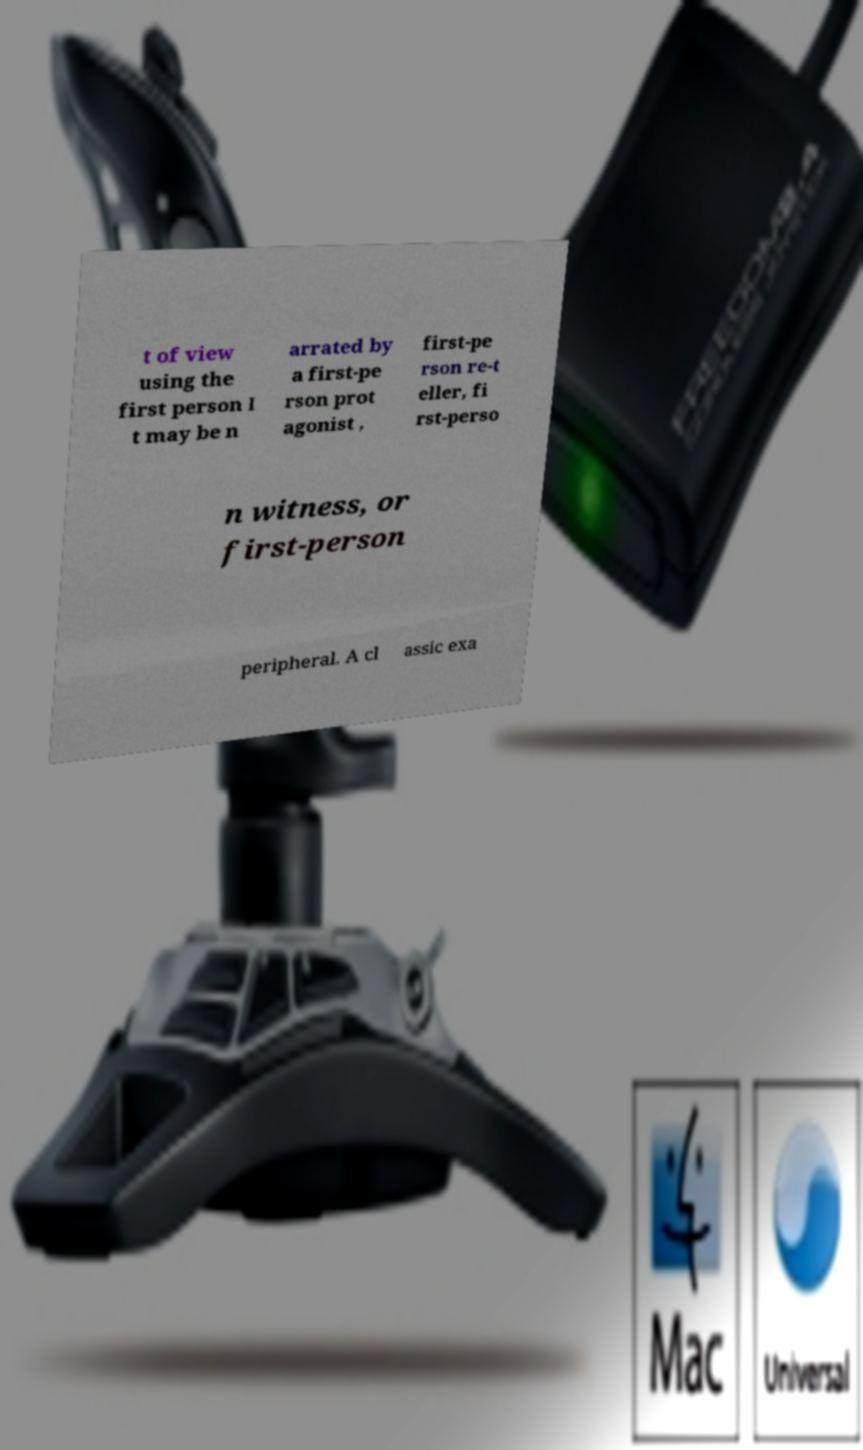I need the written content from this picture converted into text. Can you do that? t of view using the first person I t may be n arrated by a first-pe rson prot agonist , first-pe rson re-t eller, fi rst-perso n witness, or first-person peripheral. A cl assic exa 